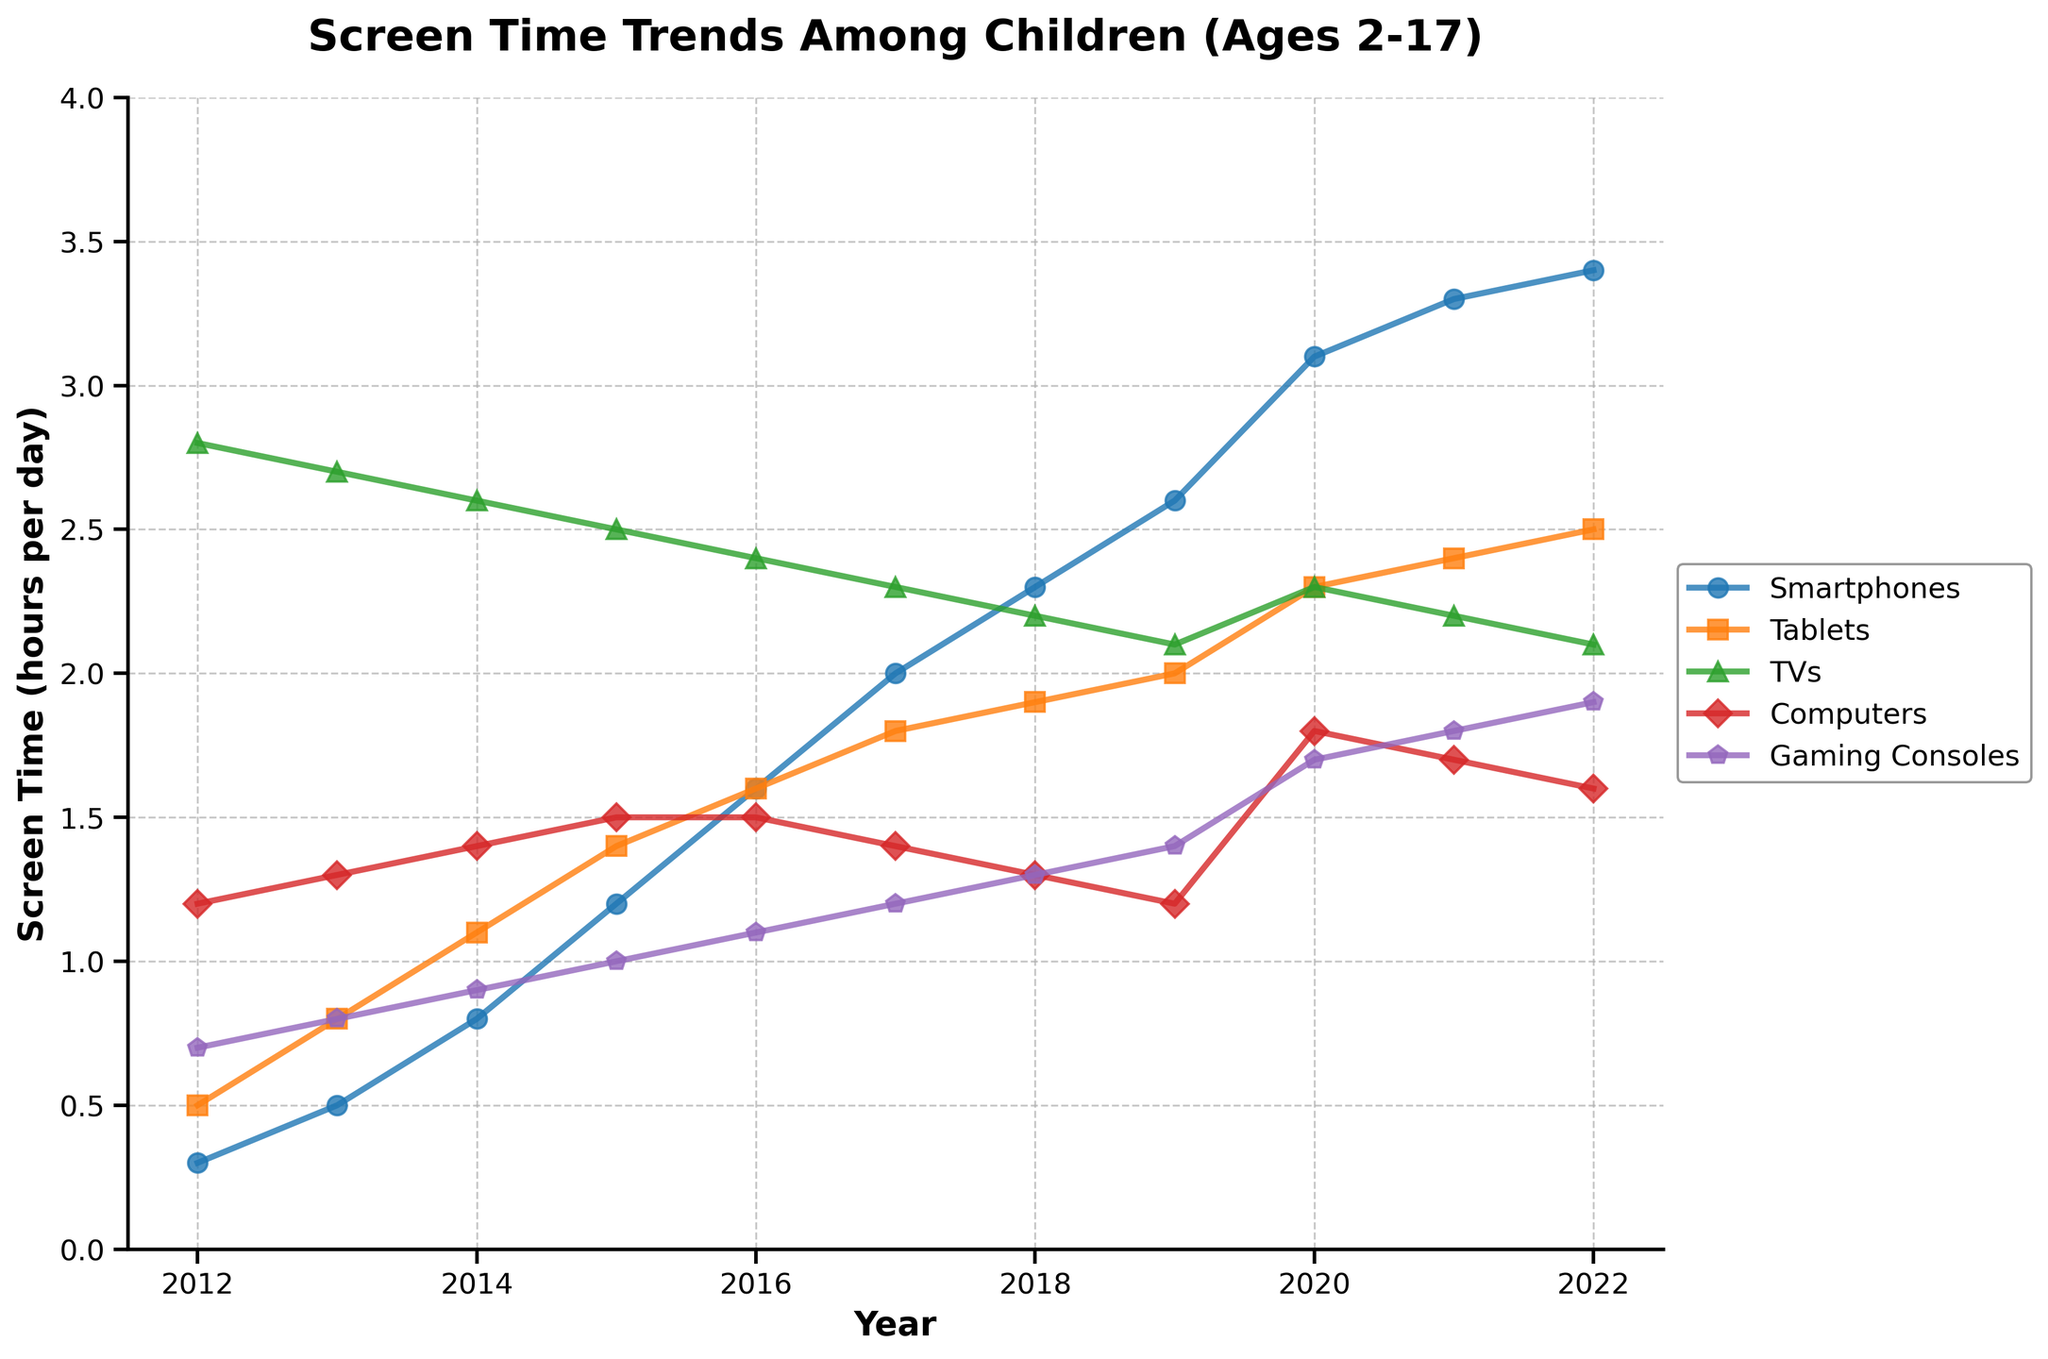What's the total screen time for Smartphones and Tablets in 2022? To find the total screen time for both devices, we add the hours per day for Smartphones and Tablets in 2022. According to the figure, Smartphones have 3.4 hours and Tablets have 2.5 hours in 2022. Therefore, the total screen time is 3.4 + 2.5 = 5.9 hours.
Answer: 5.9 hours Which device type had the largest increase in screen time from 2012 to 2022? We look at the figure and note the difference in screen time for each device type between 2012 and 2022. The increments are: Smartphones (3.4 - 0.3 = 3.1 hours), Tablets (2.5 - 0.5 = 2.0 hours), TVs (2.1 - 2.8 = -0.7 hours), Computers (1.6 - 1.2 = 0.4 hours), and Gaming Consoles (1.9 - 0.7 = 1.2 hours). Smartphones had the largest increase of 3.1 hours.
Answer: Smartphones In which year did Tablets first exceed 2 hours of screen time per day? To find the exact year Tablets first surpassed 2 hours, we locate the year on the figure's x-axis where the Tablets line crosses the 2-hour mark. According to the figure, this threshold is first met in 2019.
Answer: 2019 Compare TV usage in 2015 and 2020 and determine the difference in hours per day. From the figure, TV usage in 2015 is 2.5 hours, and in 2020 it is 2.3 hours. The difference is calculated as 2.5 - 2.3 = 0.2 hours.
Answer: 0.2 hours What is the trend in Gaming Consoles screen time between 2012 and 2022? By observing the figure, we can see that the screen time for Gaming Consoles has steadily increased from 0.7 hours in 2012 to 1.9 hours in 2022. Therefore, the trend is a consistent upward increase over the years.
Answer: Increasing consistently Which two years saw the highest screen time for Smartphones? By reviewing the figure, the years with the highest screen time for Smartphones are 2021 and 2022, with screen times of 3.3 and 3.4 hours respectively.
Answer: 2021 and 2022 What was the average screen time for Computers between 2012 and 2022? To find the average screen time for Computers, sum the screen times from 2012 to 2022 and divide by the number of years. The screen times are: 1.2, 1.3, 1.4, 1.5, 1.5, 1.4, 1.3, 1.3, 1.2, 1.8, and 1.7. Summing these gives a total of 16.6. Dividing by 11 years, the average is 16.6 / 11 = 1.51 hours per day (rounded to two decimal places).
Answer: 1.51 hours per day How did the screen time for Gaming Consoles change from 2017 to 2019? From the figure, Gaming Consoles had screen times of 1.2 hours in 2017 and 1.4 hours in 2019. The change is 1.4 - 1.2 = 0.2 hours.
Answer: Increased by 0.2 hours Which device had the most stable screen time over the years shown? From the figure, the TV screen time appears to be the most stable, with values slightly decreasing but generally hovering around the 2.1 to 2.8 hours range over the years.
Answer: TVs 